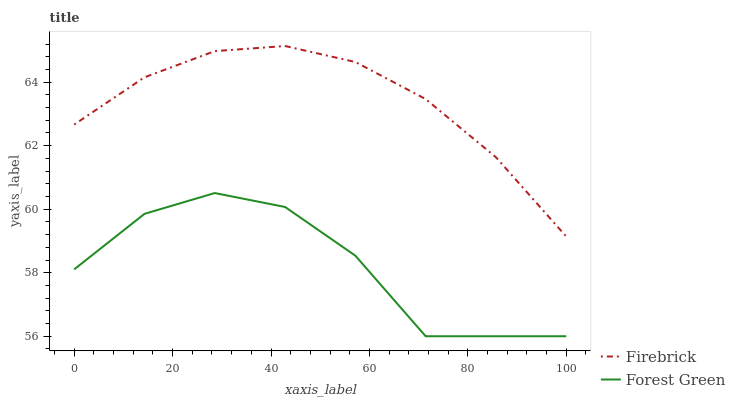Does Forest Green have the minimum area under the curve?
Answer yes or no. Yes. Does Firebrick have the maximum area under the curve?
Answer yes or no. Yes. Does Forest Green have the maximum area under the curve?
Answer yes or no. No. Is Firebrick the smoothest?
Answer yes or no. Yes. Is Forest Green the roughest?
Answer yes or no. Yes. Is Forest Green the smoothest?
Answer yes or no. No. Does Forest Green have the lowest value?
Answer yes or no. Yes. Does Firebrick have the highest value?
Answer yes or no. Yes. Does Forest Green have the highest value?
Answer yes or no. No. Is Forest Green less than Firebrick?
Answer yes or no. Yes. Is Firebrick greater than Forest Green?
Answer yes or no. Yes. Does Forest Green intersect Firebrick?
Answer yes or no. No. 